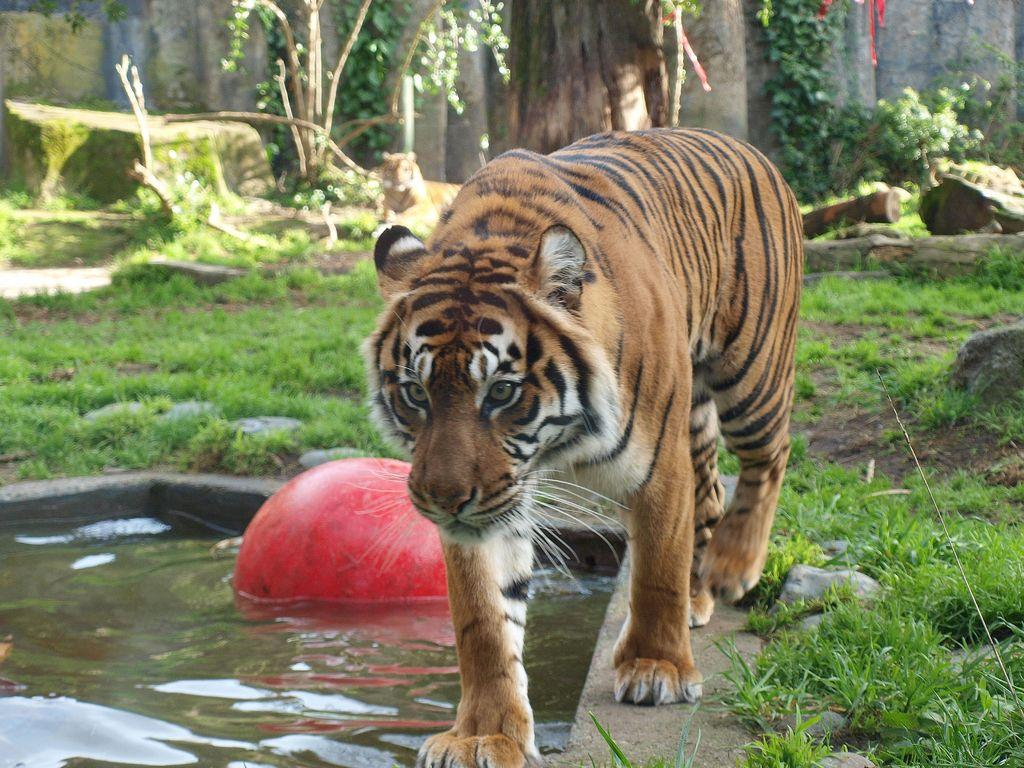What animal can be seen in the image? There is a tiger in the image. What object is in the water on the left side of the image? There is a ball in the water on the left side of the image. What type of vegetation is visible in the image? There is grass visible in the image. What can be seen in the background of the image? There are plants in the background of the image. What type of sack is being used to design the star in the image? There is no sack or star present in the image. 